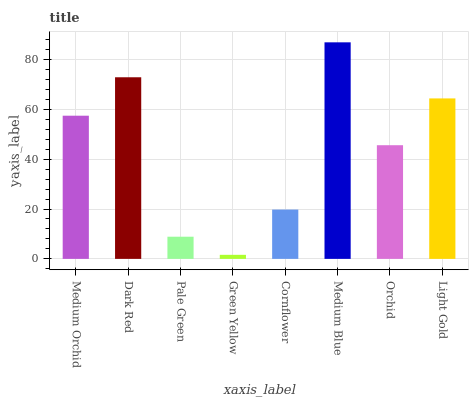Is Green Yellow the minimum?
Answer yes or no. Yes. Is Medium Blue the maximum?
Answer yes or no. Yes. Is Dark Red the minimum?
Answer yes or no. No. Is Dark Red the maximum?
Answer yes or no. No. Is Dark Red greater than Medium Orchid?
Answer yes or no. Yes. Is Medium Orchid less than Dark Red?
Answer yes or no. Yes. Is Medium Orchid greater than Dark Red?
Answer yes or no. No. Is Dark Red less than Medium Orchid?
Answer yes or no. No. Is Medium Orchid the high median?
Answer yes or no. Yes. Is Orchid the low median?
Answer yes or no. Yes. Is Medium Blue the high median?
Answer yes or no. No. Is Cornflower the low median?
Answer yes or no. No. 